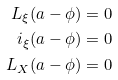<formula> <loc_0><loc_0><loc_500><loc_500>L _ { \xi } ( a - \phi ) & = 0 \\ i _ { \xi } ( a - \phi ) & = 0 \\ L _ { X } ( a - \phi ) & = 0</formula> 